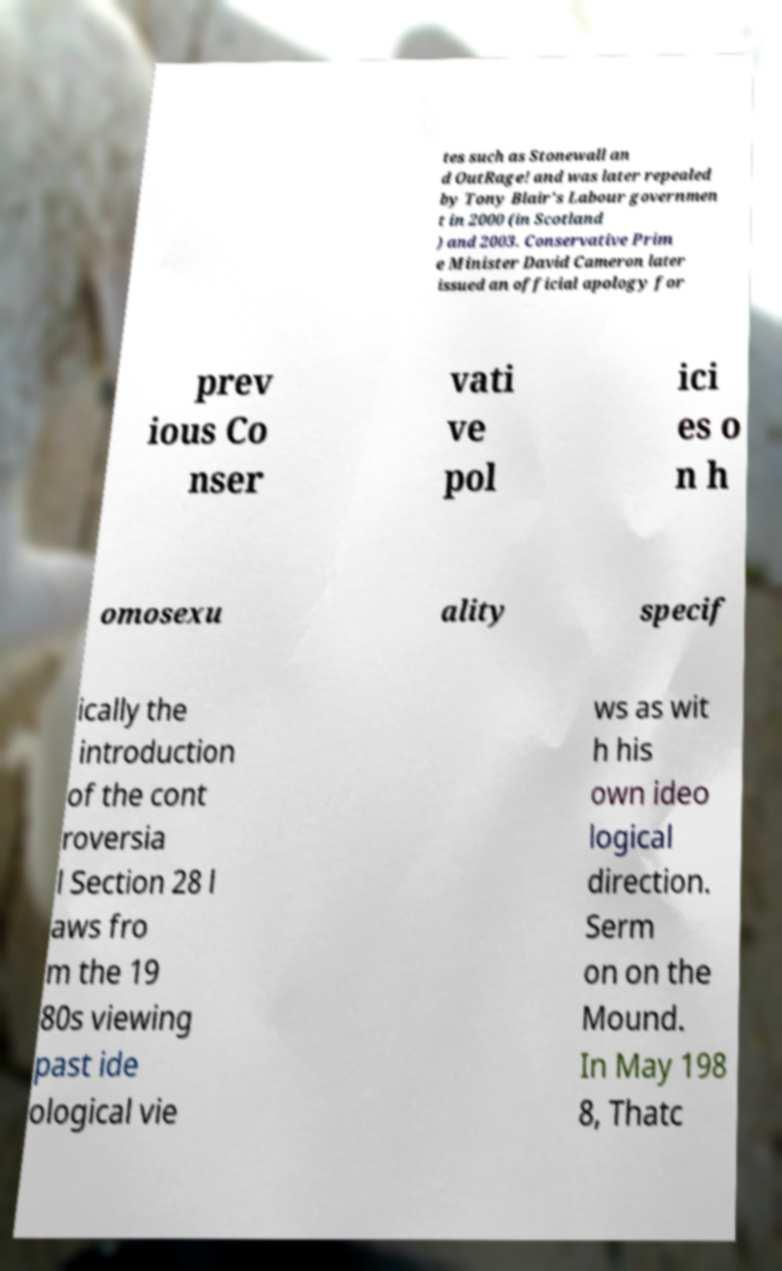Can you read and provide the text displayed in the image?This photo seems to have some interesting text. Can you extract and type it out for me? tes such as Stonewall an d OutRage! and was later repealed by Tony Blair's Labour governmen t in 2000 (in Scotland ) and 2003. Conservative Prim e Minister David Cameron later issued an official apology for prev ious Co nser vati ve pol ici es o n h omosexu ality specif ically the introduction of the cont roversia l Section 28 l aws fro m the 19 80s viewing past ide ological vie ws as wit h his own ideo logical direction. Serm on on the Mound. In May 198 8, Thatc 